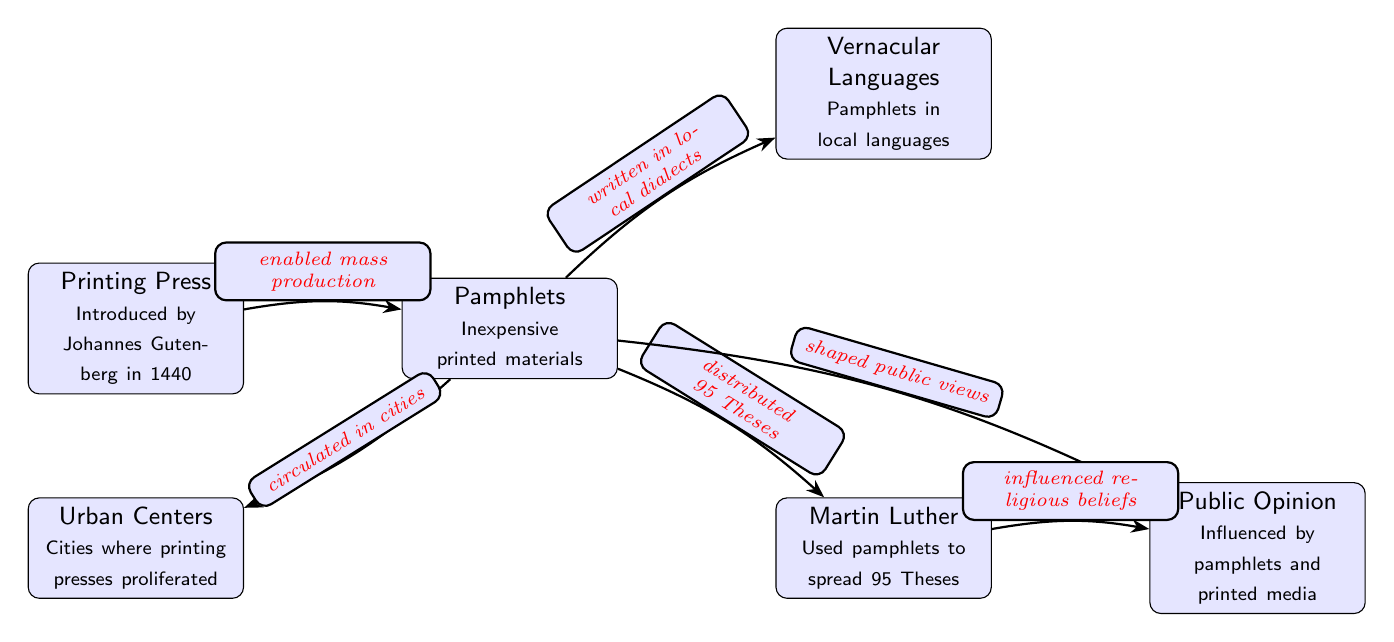What invention enabled mass production of printed media? The diagram specifies that the invention of the Printing Press by Johannes Gutenberg in 1440 enabled the mass production of printed media. This is evidenced by the arrow labeled "enabled mass production" leading from the Printing Press to Pamphlets.
Answer: Printing Press What were pamphlets in the context of the Reformation? According to the diagram, pamphlets are described as inexpensive printed materials. This is directly mentioned in the node labeled "Pamphlets."
Answer: Inexpensive printed materials Who used pamphlets to spread the 95 Theses? The diagram indicates that Martin Luther was the individual who used pamphlets to spread the 95 Theses, as shown in the node below right of the Pamphlets labeled "Martin Luther."
Answer: Martin Luther How did vernacular languages contribute to the dissemination of pamphlets? The diagram shows an arrow from Pamphlets to the Vernacular Languages node, labeled "written in local dialects." This suggests that pamphlets were written in local dialects, making them accessible to a broader audience.
Answer: Written in local dialects What role did urban centers play in the circulation of pamphlets? The diagram illustrates a relationship where pamphlets circulated in cities, as indicated by the arrow labeled "circulated in cities" leading from Pamphlets to Urban Centers. This highlights the role of urban centers in the spread of pamphlets.
Answer: Circulated in cities How did Martin Luther influence public opinion? The diagram shows a connection between Martin Luther and Public Opinion, with an arrow labeled "influenced religious beliefs." This implies that Martin Luther’s actions played a significant role in shaping public opinion, particularly regarding religious beliefs.
Answer: Influenced religious beliefs What was the effect of pamphlets on public views according to the diagram? The node labeled "Public Opinion" is connected to pamphlets through an edge labeled "shaped public views." This indicates that pamphlets had a direct impact on shaping the public's views during the Reformation era.
Answer: Shaped public views How many nodes are there in this diagram? By counting all individual entities (nodes) represented in the diagram, there are a total of 6 nodes: Printing Press, Pamphlets, Martin Luther, Vernacular Languages, Urban Centers, and Public Opinion.
Answer: 6 How did the introduction of the printing press impact the availability of pamphlets? The diagram indicates that the Printing Press enabled mass production, which directly led to the proliferation of pamphlets (as shown by the arrow "enabled mass production" leading to Pamphlets). Thus, it significantly increased the availability of pamphlets.
Answer: Increased availability 